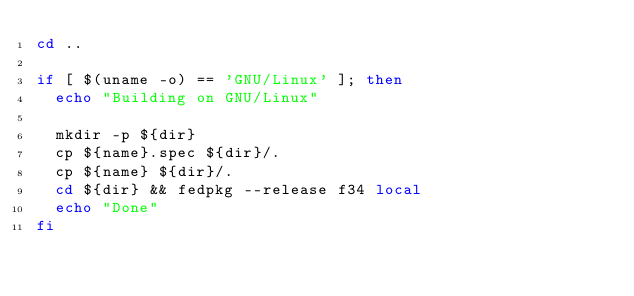Convert code to text. <code><loc_0><loc_0><loc_500><loc_500><_Bash_>cd ..

if [ $(uname -o) == 'GNU/Linux' ]; then
  echo "Building on GNU/Linux"

  mkdir -p ${dir}
  cp ${name}.spec ${dir}/.
  cp ${name} ${dir}/.
  cd ${dir} && fedpkg --release f34 local
  echo "Done"
fi
</code> 